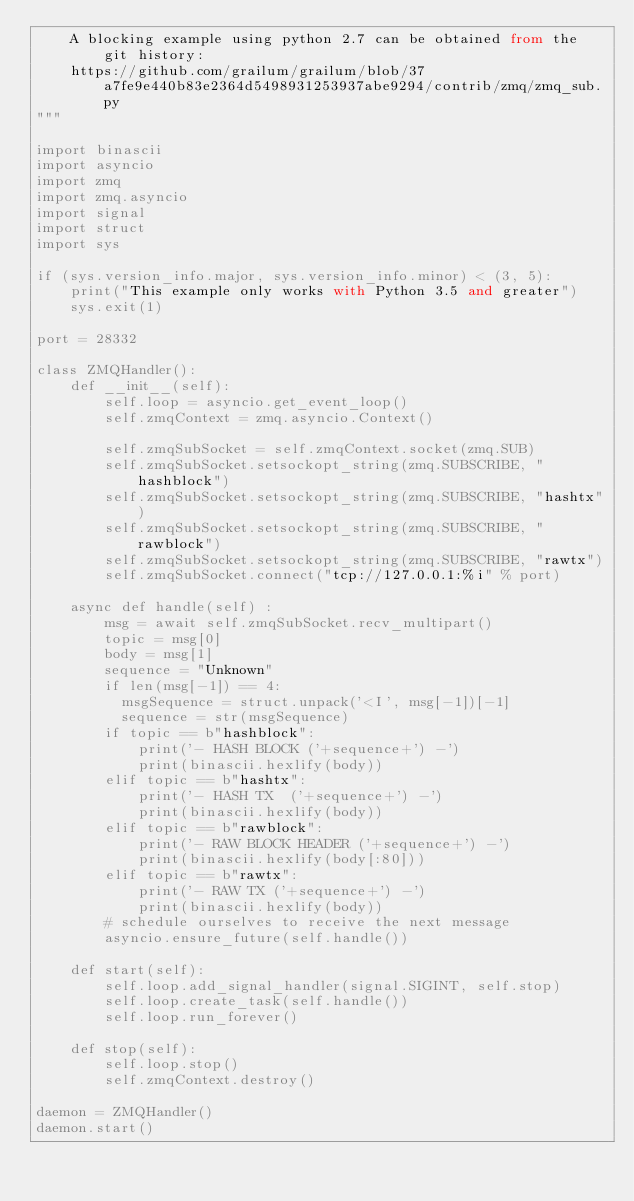Convert code to text. <code><loc_0><loc_0><loc_500><loc_500><_Python_>    A blocking example using python 2.7 can be obtained from the git history:
    https://github.com/grailum/grailum/blob/37a7fe9e440b83e2364d5498931253937abe9294/contrib/zmq/zmq_sub.py
"""

import binascii
import asyncio
import zmq
import zmq.asyncio
import signal
import struct
import sys

if (sys.version_info.major, sys.version_info.minor) < (3, 5):
    print("This example only works with Python 3.5 and greater")
    sys.exit(1)

port = 28332

class ZMQHandler():
    def __init__(self):
        self.loop = asyncio.get_event_loop()
        self.zmqContext = zmq.asyncio.Context()

        self.zmqSubSocket = self.zmqContext.socket(zmq.SUB)
        self.zmqSubSocket.setsockopt_string(zmq.SUBSCRIBE, "hashblock")
        self.zmqSubSocket.setsockopt_string(zmq.SUBSCRIBE, "hashtx")
        self.zmqSubSocket.setsockopt_string(zmq.SUBSCRIBE, "rawblock")
        self.zmqSubSocket.setsockopt_string(zmq.SUBSCRIBE, "rawtx")
        self.zmqSubSocket.connect("tcp://127.0.0.1:%i" % port)

    async def handle(self) :
        msg = await self.zmqSubSocket.recv_multipart()
        topic = msg[0]
        body = msg[1]
        sequence = "Unknown"
        if len(msg[-1]) == 4:
          msgSequence = struct.unpack('<I', msg[-1])[-1]
          sequence = str(msgSequence)
        if topic == b"hashblock":
            print('- HASH BLOCK ('+sequence+') -')
            print(binascii.hexlify(body))
        elif topic == b"hashtx":
            print('- HASH TX  ('+sequence+') -')
            print(binascii.hexlify(body))
        elif topic == b"rawblock":
            print('- RAW BLOCK HEADER ('+sequence+') -')
            print(binascii.hexlify(body[:80]))
        elif topic == b"rawtx":
            print('- RAW TX ('+sequence+') -')
            print(binascii.hexlify(body))
        # schedule ourselves to receive the next message
        asyncio.ensure_future(self.handle())

    def start(self):
        self.loop.add_signal_handler(signal.SIGINT, self.stop)
        self.loop.create_task(self.handle())
        self.loop.run_forever()

    def stop(self):
        self.loop.stop()
        self.zmqContext.destroy()

daemon = ZMQHandler()
daemon.start()
</code> 